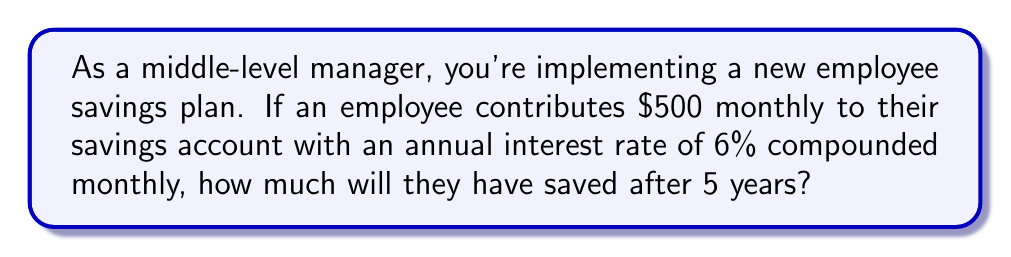Could you help me with this problem? To solve this problem, we'll use the compound interest formula for regular contributions:

$$A = P \cdot \frac{(1 + r)^n - 1}{r} \cdot (1 + r)$$

Where:
$A$ = Final amount
$P$ = Regular payment amount
$r$ = Interest rate per compounding period
$n$ = Number of compounding periods

Step 1: Calculate the monthly interest rate
$r = \frac{6\%}{12} = 0.005$ or $0.5\%$ per month

Step 2: Calculate the number of compounding periods
$n = 5 \text{ years} \times 12 \text{ months} = 60$ periods

Step 3: Apply the formula
$$\begin{align}
A &= 500 \cdot \frac{(1 + 0.005)^{60} - 1}{0.005} \cdot (1 + 0.005) \\
&= 500 \cdot \frac{1.3489 - 1}{0.005} \cdot 1.005 \\
&= 500 \cdot 69.78 \cdot 1.005 \\
&= 35,064.45
\end{align}$$

Therefore, after 5 years, the employee will have saved $35,064.45.
Answer: $35,064.45 